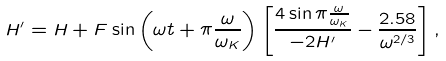<formula> <loc_0><loc_0><loc_500><loc_500>H ^ { \prime } = H + F \sin \left ( \omega t + \pi \frac { \omega } { \omega _ { K } } \right ) \left [ \frac { 4 \sin \pi \frac { \omega } { \omega _ { K } } } { - 2 H ^ { \prime } } - \frac { 2 . 5 8 } { \omega ^ { 2 / 3 } } \right ] ,</formula> 